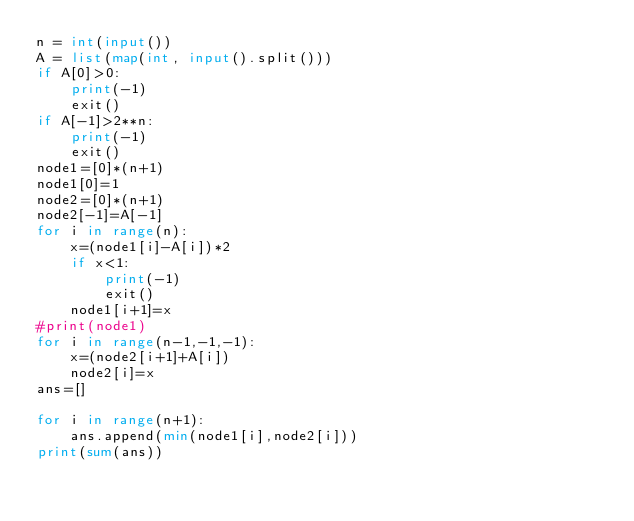Convert code to text. <code><loc_0><loc_0><loc_500><loc_500><_Python_>n = int(input())
A = list(map(int, input().split()))
if A[0]>0:
    print(-1)
    exit()
if A[-1]>2**n:
    print(-1)
    exit()
node1=[0]*(n+1)
node1[0]=1
node2=[0]*(n+1)
node2[-1]=A[-1]
for i in range(n):
    x=(node1[i]-A[i])*2
    if x<1:
        print(-1)
        exit()
    node1[i+1]=x
#print(node1)
for i in range(n-1,-1,-1):
    x=(node2[i+1]+A[i])
    node2[i]=x
ans=[]

for i in range(n+1):
    ans.append(min(node1[i],node2[i]))
print(sum(ans))
</code> 